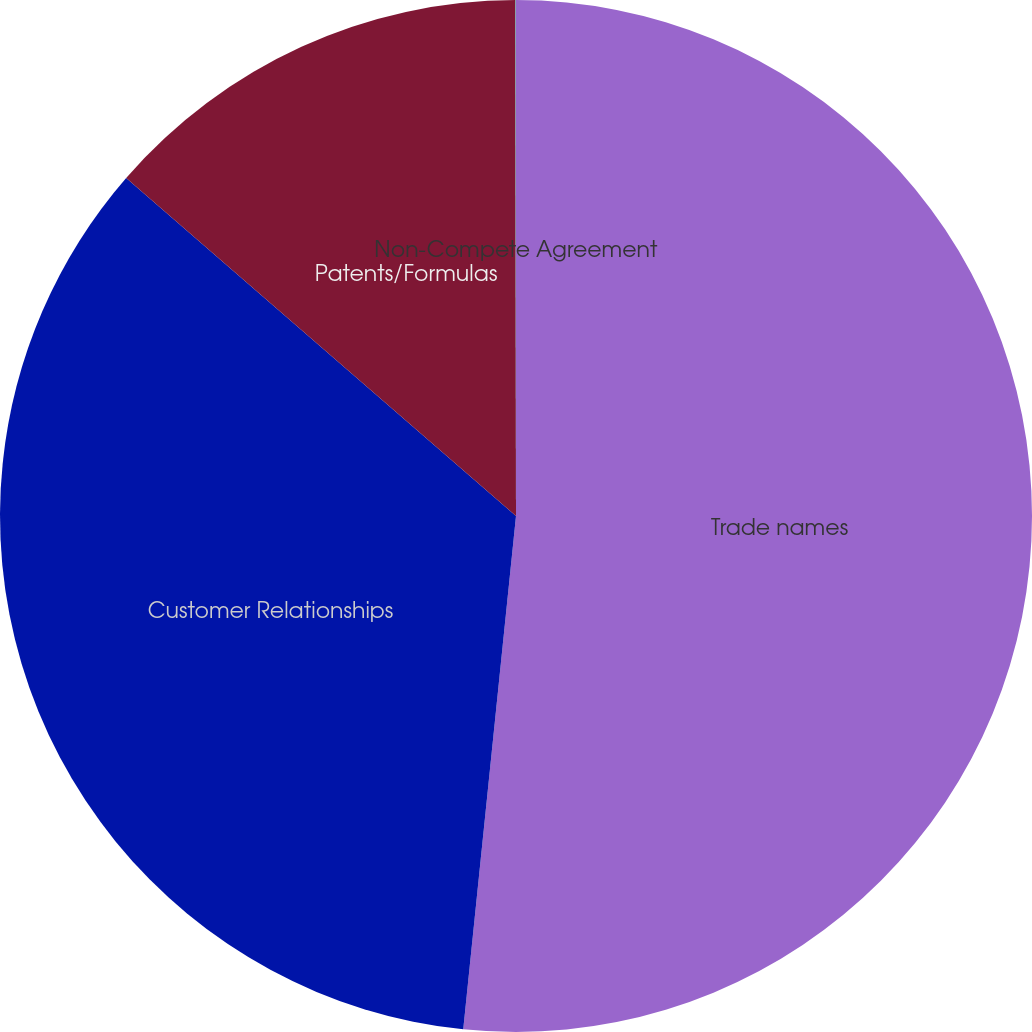Convert chart. <chart><loc_0><loc_0><loc_500><loc_500><pie_chart><fcel>Trade names<fcel>Customer Relationships<fcel>Patents/Formulas<fcel>Non-Compete Agreement<nl><fcel>51.63%<fcel>34.74%<fcel>13.61%<fcel>0.02%<nl></chart> 